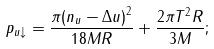<formula> <loc_0><loc_0><loc_500><loc_500>p _ { u \downarrow } = \frac { \pi { ( n _ { u } - \Delta u ) } ^ { 2 } } { 1 8 M R } + \frac { 2 \pi { T } ^ { 2 } R } { 3 M } ;</formula> 